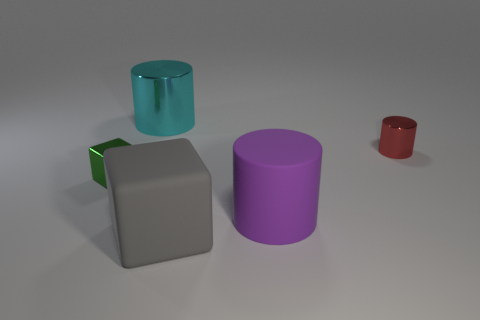Add 1 yellow rubber balls. How many objects exist? 6 Subtract all cylinders. How many objects are left? 2 Subtract 0 gray cylinders. How many objects are left? 5 Subtract all big purple shiny objects. Subtract all large cyan metal objects. How many objects are left? 4 Add 3 cyan objects. How many cyan objects are left? 4 Add 1 big cyan shiny objects. How many big cyan shiny objects exist? 2 